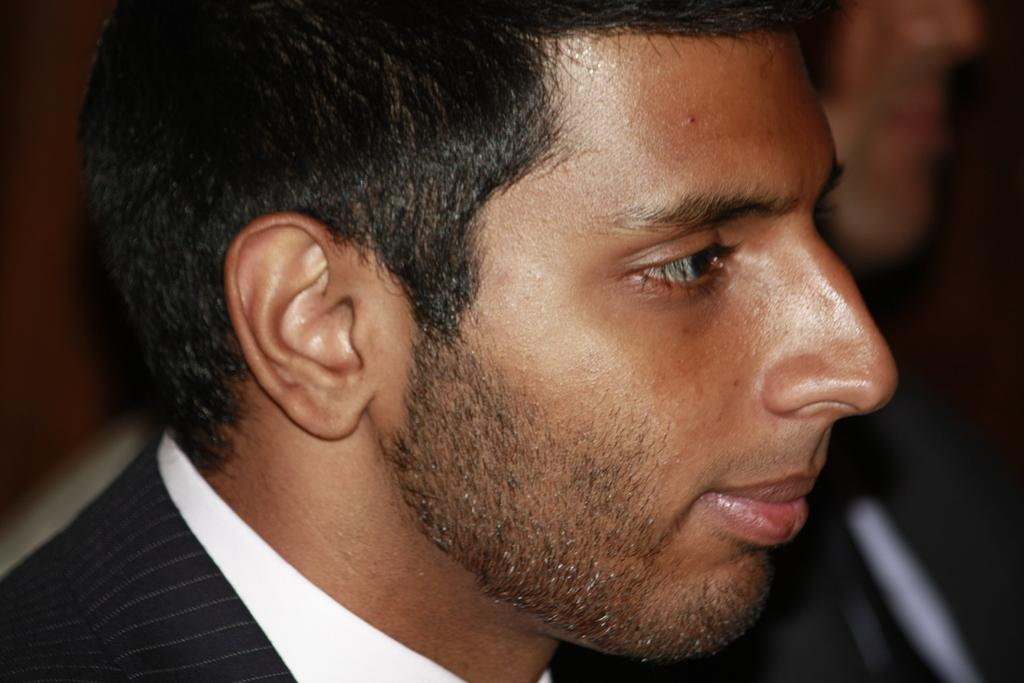Who is present in the image? There is a man in the image. Can you describe the background of the image? The background of the image is blurry. What type of machine is the expert using in the image? There is no machine or expert present in the image; it only features a man and a blurry background. 